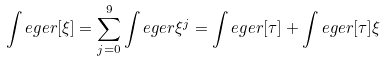<formula> <loc_0><loc_0><loc_500><loc_500>\int e g e r [ \xi ] = \sum _ { j = 0 } ^ { 9 } \int e g e r \xi ^ { j } = \int e g e r [ \tau ] + \int e g e r [ \tau ] \xi</formula> 